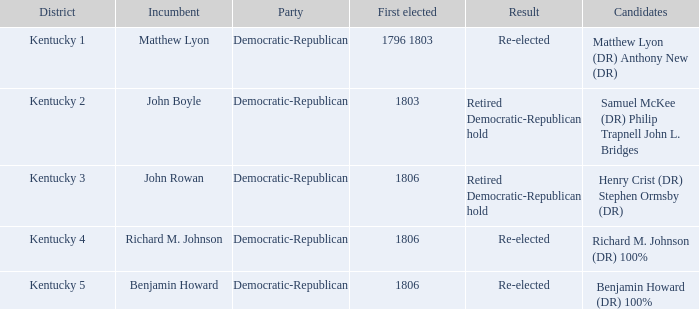Who currently holds the positions that matthew lyon (dr) and anthony new (dr) once held? Matthew Lyon. 